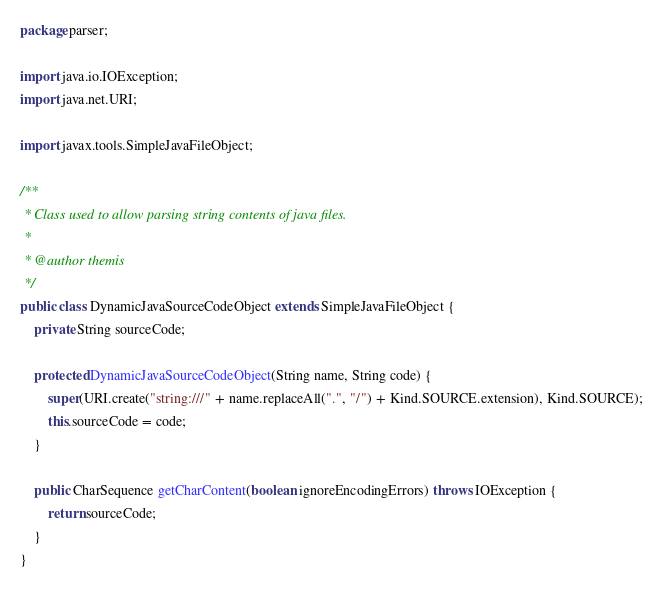Convert code to text. <code><loc_0><loc_0><loc_500><loc_500><_Java_>package parser;

import java.io.IOException;
import java.net.URI;

import javax.tools.SimpleJavaFileObject;

/**
 * Class used to allow parsing string contents of java files.
 * 
 * @author themis
 */
public class DynamicJavaSourceCodeObject extends SimpleJavaFileObject {
	private String sourceCode;

	protected DynamicJavaSourceCodeObject(String name, String code) {
		super(URI.create("string:///" + name.replaceAll(".", "/") + Kind.SOURCE.extension), Kind.SOURCE);
		this.sourceCode = code;
	}

	public CharSequence getCharContent(boolean ignoreEncodingErrors) throws IOException {
		return sourceCode;
	}
}
</code> 